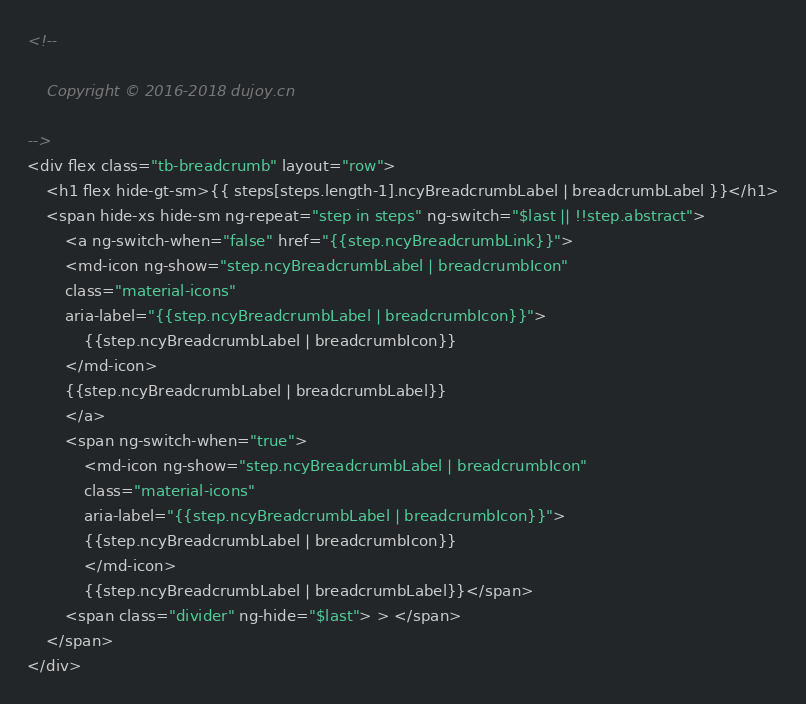<code> <loc_0><loc_0><loc_500><loc_500><_HTML_><!--

    Copyright © 2016-2018 dujoy.cn

-->
<div flex class="tb-breadcrumb" layout="row">
	<h1 flex hide-gt-sm>{{ steps[steps.length-1].ncyBreadcrumbLabel | breadcrumbLabel }}</h1>
	<span hide-xs hide-sm ng-repeat="step in steps" ng-switch="$last || !!step.abstract">
	    <a ng-switch-when="false" href="{{step.ncyBreadcrumbLink}}">
	    <md-icon ng-show="step.ncyBreadcrumbLabel | breadcrumbIcon" 
	    class="material-icons"
	    aria-label="{{step.ncyBreadcrumbLabel | breadcrumbIcon}}">
	    	{{step.ncyBreadcrumbLabel | breadcrumbIcon}}
	    </md-icon>
	    {{step.ncyBreadcrumbLabel | breadcrumbLabel}}
	    </a>
	    <span ng-switch-when="true">
	    	<md-icon ng-show="step.ncyBreadcrumbLabel | breadcrumbIcon" 
	    	class="material-icons"
	    	aria-label="{{step.ncyBreadcrumbLabel | breadcrumbIcon}}">
	    	{{step.ncyBreadcrumbLabel | breadcrumbIcon}}
	    	</md-icon>
	    	{{step.ncyBreadcrumbLabel | breadcrumbLabel}}</span>
	    <span class="divider" ng-hide="$last"> > </span>
	</span>
</div>
</code> 